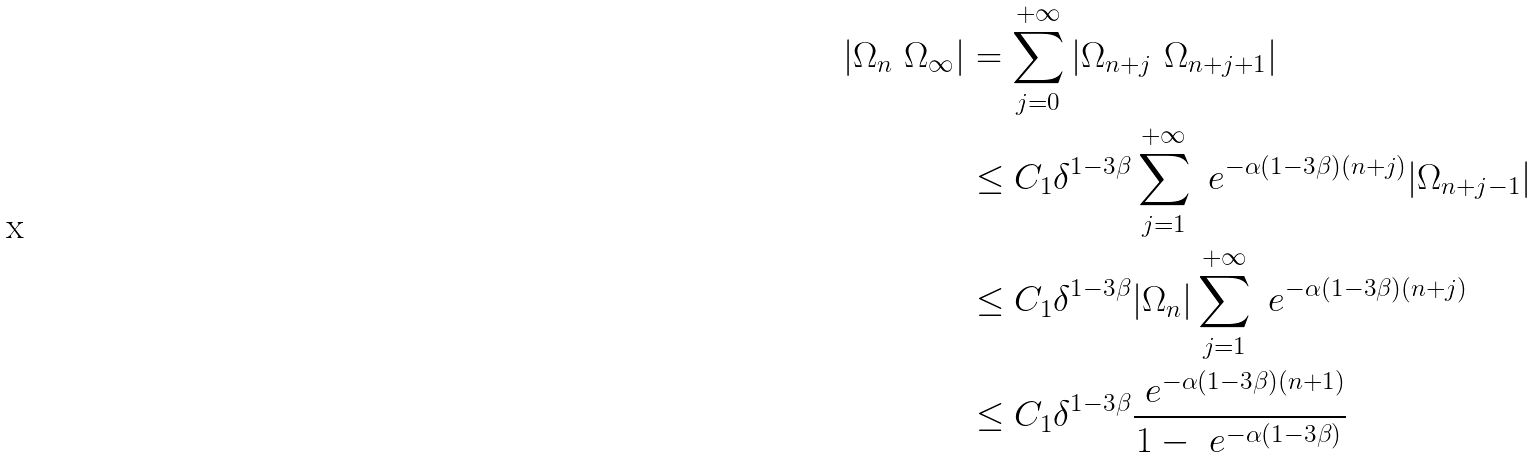<formula> <loc_0><loc_0><loc_500><loc_500>| \Omega _ { n } \ \Omega _ { \infty } | & = \sum _ { j = 0 } ^ { + \infty } | \Omega _ { n + j } \ \Omega _ { n + j + 1 } | \\ & \leq C _ { 1 } \delta ^ { 1 - 3 \beta } \sum _ { j = 1 } ^ { + \infty } \ e ^ { - \alpha ( 1 - 3 \beta ) ( n + j ) } | \Omega _ { n + j - 1 } | \\ & \leq C _ { 1 } \delta ^ { 1 - 3 \beta } | \Omega _ { n } | \sum _ { j = 1 } ^ { + \infty } \ e ^ { - \alpha ( 1 - 3 \beta ) ( n + j ) } \\ & \leq C _ { 1 } \delta ^ { 1 - 3 \beta } \frac { \ e ^ { - \alpha ( 1 - 3 \beta ) ( n + 1 ) } } { 1 - \ e ^ { - \alpha ( 1 - 3 \beta ) } }</formula> 